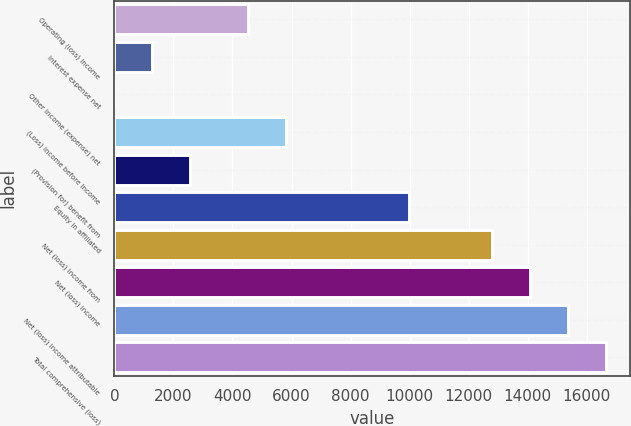<chart> <loc_0><loc_0><loc_500><loc_500><bar_chart><fcel>Operating (loss) income<fcel>Interest expense net<fcel>Other income (expense) net<fcel>(Loss) income before income<fcel>(Provision for) benefit from<fcel>Equity in affiliated<fcel>Net (loss) income from<fcel>Net (loss) income<fcel>Net (loss) income attributable<fcel>Total comprehensive (loss)<nl><fcel>4537<fcel>1281.1<fcel>1<fcel>5817.1<fcel>2561.2<fcel>9976<fcel>12802<fcel>14082.1<fcel>15362.2<fcel>16642.3<nl></chart> 